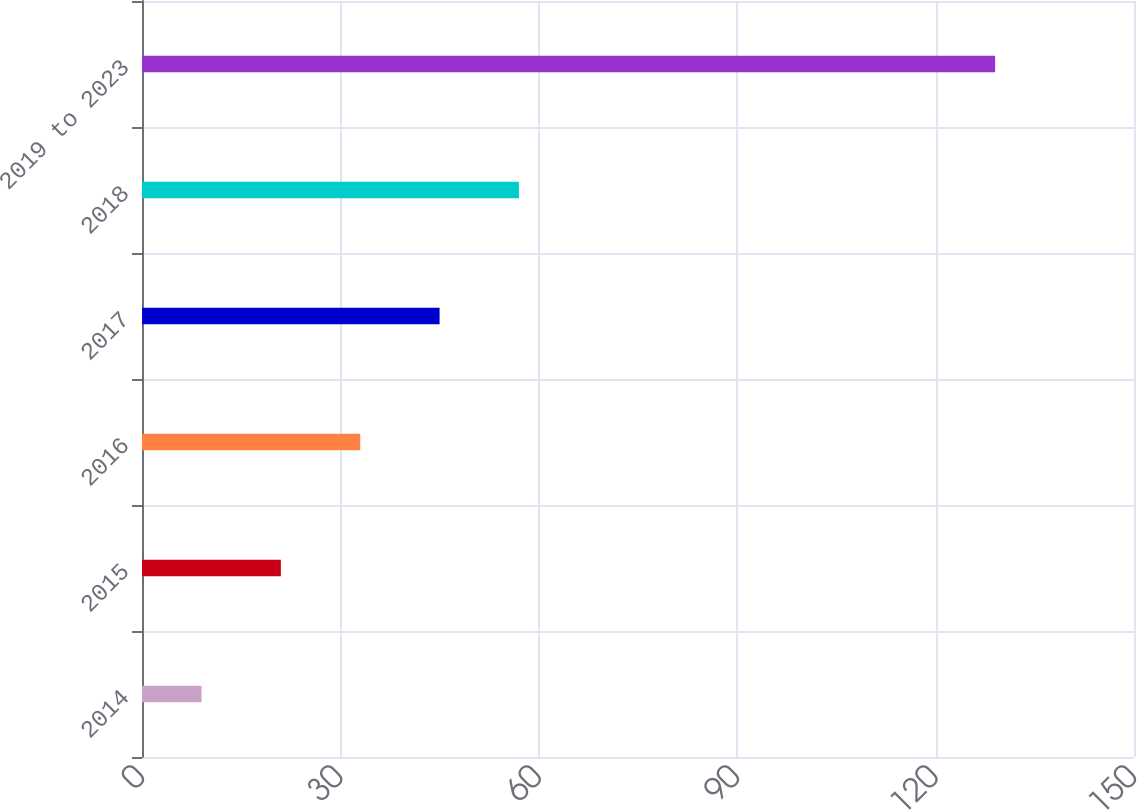Convert chart. <chart><loc_0><loc_0><loc_500><loc_500><bar_chart><fcel>2014<fcel>2015<fcel>2016<fcel>2017<fcel>2018<fcel>2019 to 2023<nl><fcel>9<fcel>21<fcel>33<fcel>45<fcel>57<fcel>129<nl></chart> 